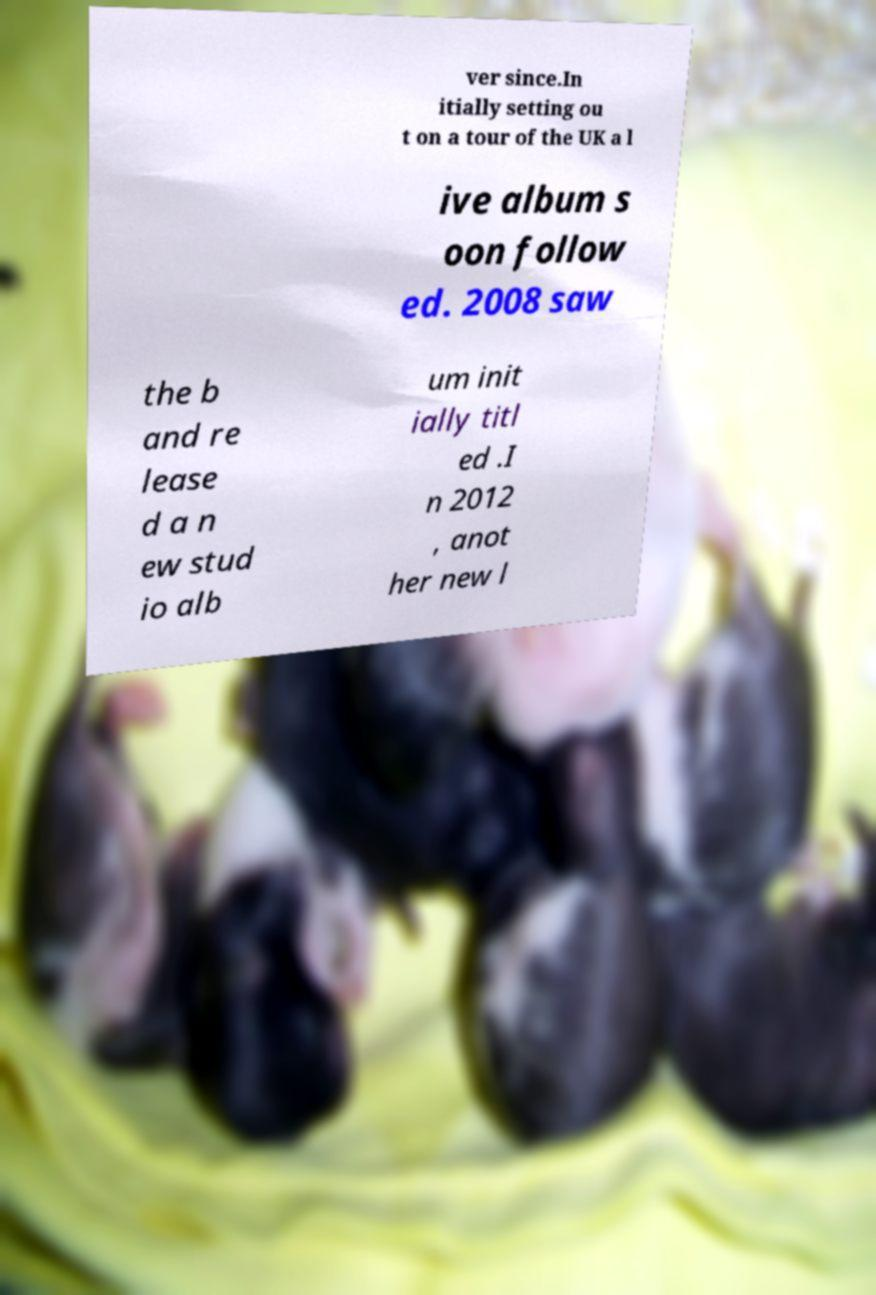I need the written content from this picture converted into text. Can you do that? ver since.In itially setting ou t on a tour of the UK a l ive album s oon follow ed. 2008 saw the b and re lease d a n ew stud io alb um init ially titl ed .I n 2012 , anot her new l 